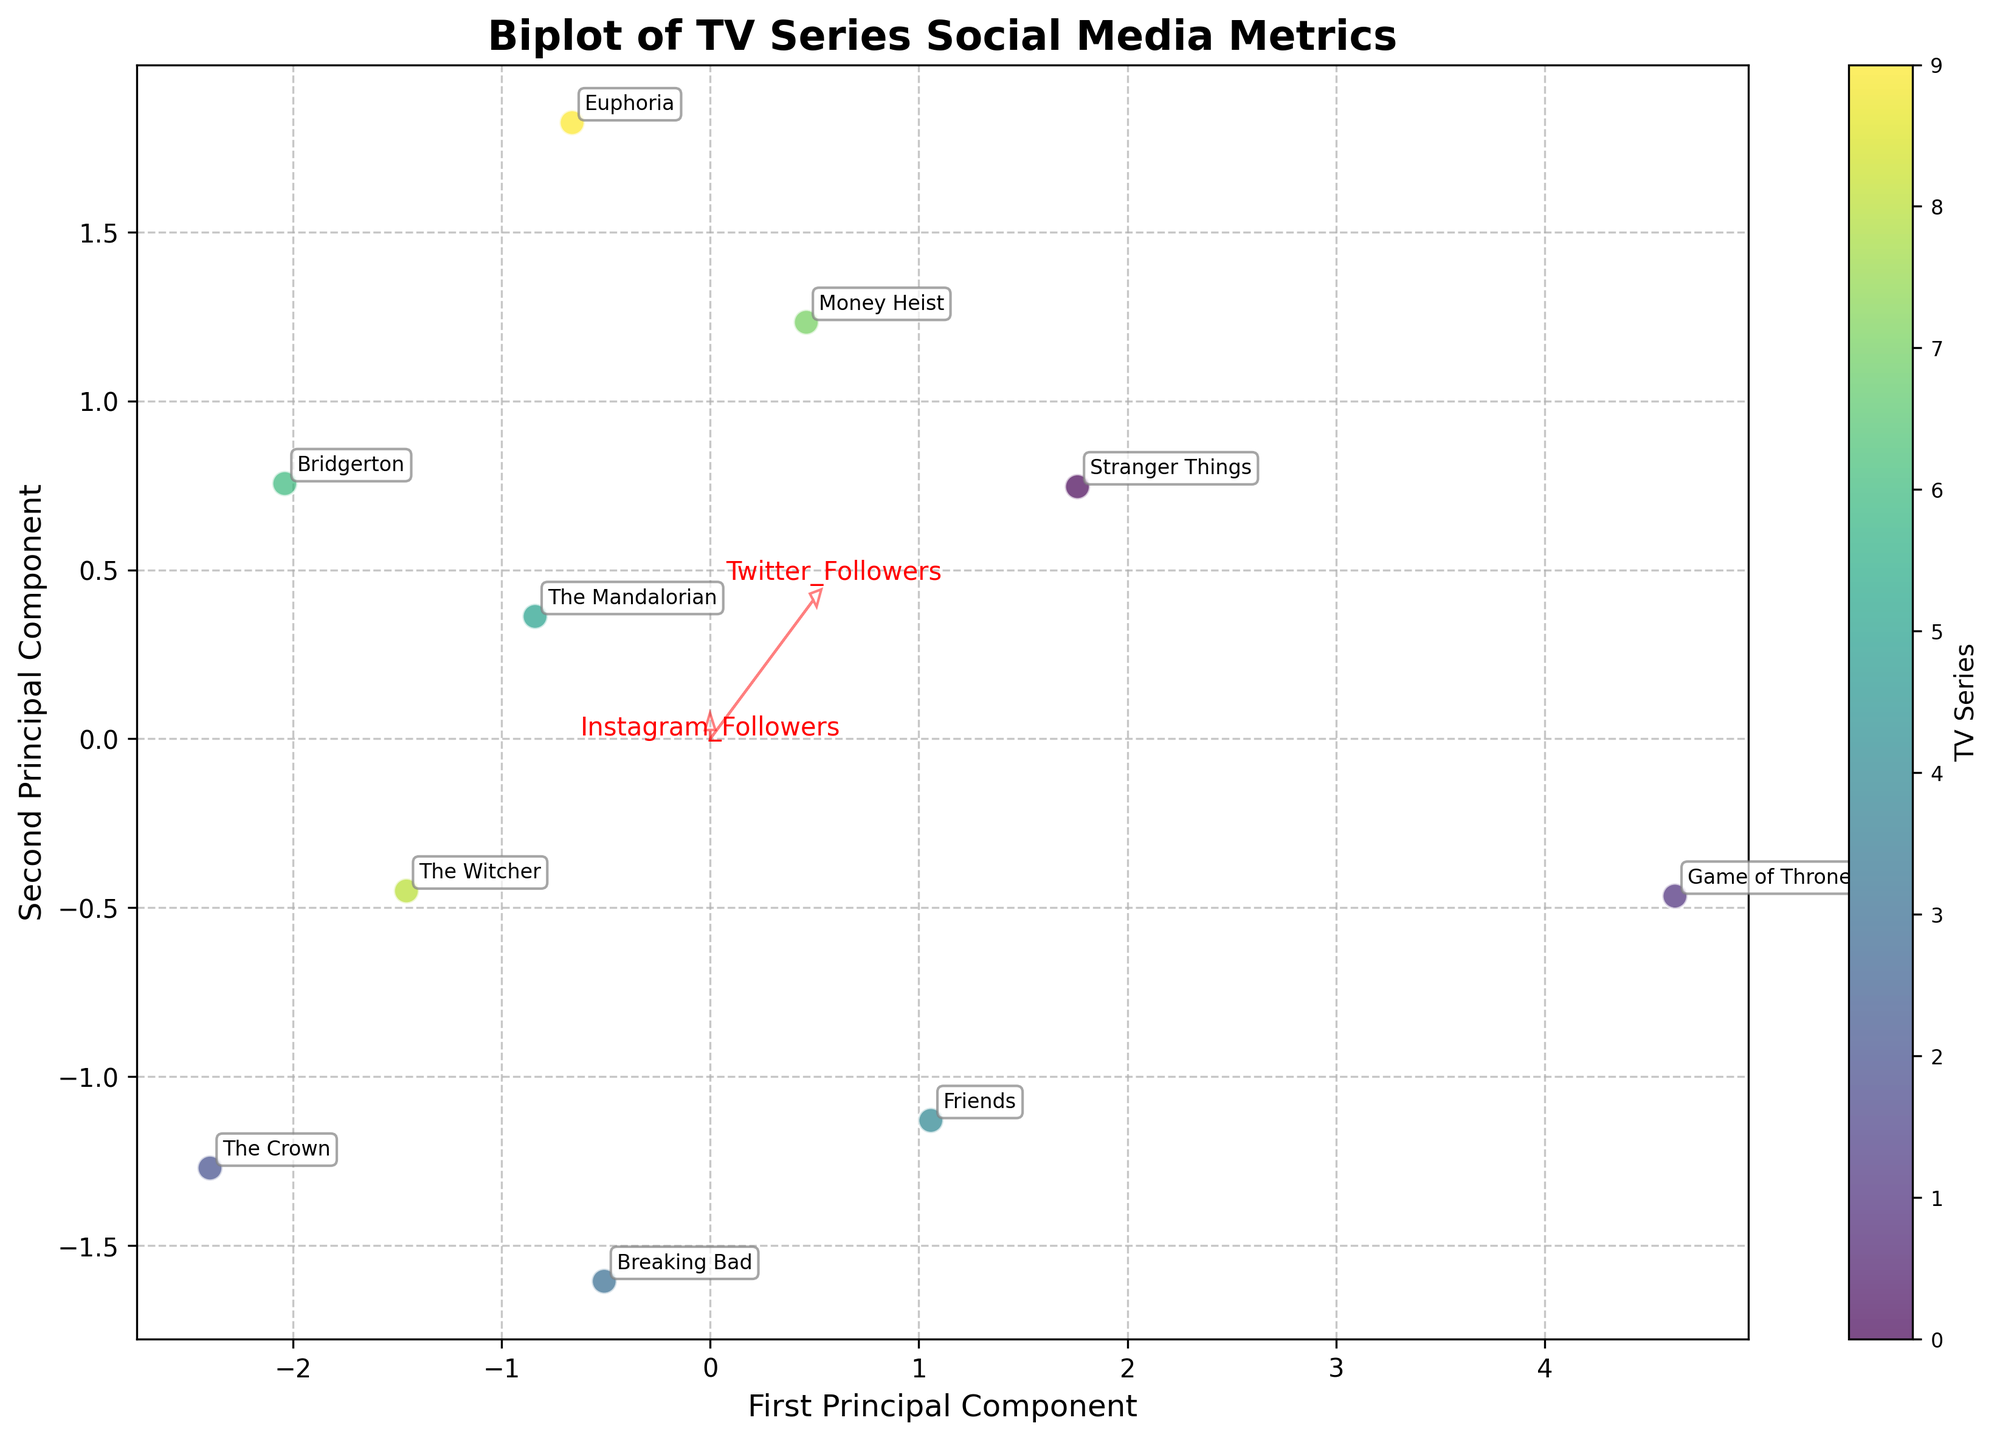Which axis represents the First Principal Component? The figure labels the horizontal axis as the "First Principal Component," which means this axis represents the first principal component derived from PCA.
Answer: Horizontal axis How many television series are depicted in the plot? Each point in the biplot represents a television series, and annotations for each series are provided. Counting the annotations gives us a total of 10 television series.
Answer: 10 Which series has the highest score on the first principal component? To identify this, look at the series with the farthest point to the right along the horizontal axis since it represents the first principal component. That series is "Game of Thrones."
Answer: Game of Thrones Which feature has the largest influence on the second principal component? The influence of features is depicted by arrows; the longer the arrow, the greater the influence. Looking at the arrows, "Weekly Facebook Engagements" has the largest influence along the vertical axis.
Answer: Weekly Facebook Engagements Compare the social media engagement metrics of "Stranger Things" and "Friends" based on their placement in the biplot. By looking at their relative positions in the biplot, "Stranger Things" is closer to "Average Tweets per Episode" and "Instagram Followers," while "Friends" is closer to "Facebook Likes" and "Instagram Stories per Week." This indicates that "Stranger Things" excels more in Twitter followers and tweets per episode, whereas "Friends" excels in Facebook likes and Instagram stories.
Answer: Stranger Things: Twitter followers, tweets per episode; Friends: Facebook likes, Instagram stories Which two series are closest to each other in terms of their social media engagement metrics? The Euclidean distance on the biplot indicates how similar the series are in terms of their social media metrics. The closest series are "The Mandalorian" and "The Crown," which are positioned close to each other.
Answer: The Mandalorian and The Crown Why might "Money Heist" have a high score on both principal components? "Money Heist" has a high score on both axes, indicating strong performance across multiple social media metrics. This suggests it has consistently high values in factors like Twitter and Instagram followers, Facebook engagements, tweets per episode, and Instagram stories. The combination of all these strong metrics gives it a high composite score.
Answer: Strong across multiple metrics How does "The Witcher" compare with "Euphoria" in terms of social media engagement metrics? "The Witcher" and "Euphoria" are plotted relatively far apart. "Euphoria" is associated more with "Instagram Stories per Week" and "Average Tweets per Episode," while "The Witcher" is aligned more with "Facebook Likes" and "Weekly Facebook Engagements." This implies "Euphoria" has more Instagram stories and tweets per episode, while "The Witcher" has more Facebook likes and engagements.
Answer: Euphoria: More Instagram stories and tweets per episode; The Witcher: More Facebook likes and engagements What does the direction of the "Instagram Followers" vector indicate about its correlation with the principal components? The "Instagram Followers" vector points strongly in between the first and second principal components at an angle, suggesting that "Instagram Followers" are significantly correlated with both principal components. This means both components capture a substantial part of the variability explained by Instagram followers.
Answer: Correlated with both components 